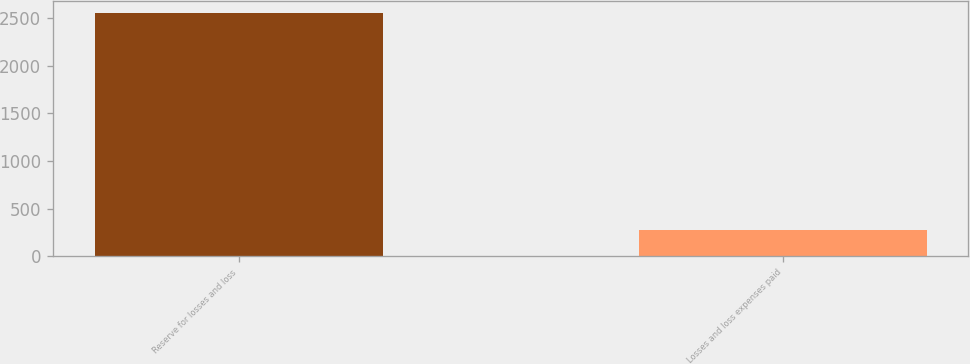Convert chart. <chart><loc_0><loc_0><loc_500><loc_500><bar_chart><fcel>Reserve for losses and loss<fcel>Losses and loss expenses paid<nl><fcel>2559<fcel>271<nl></chart> 